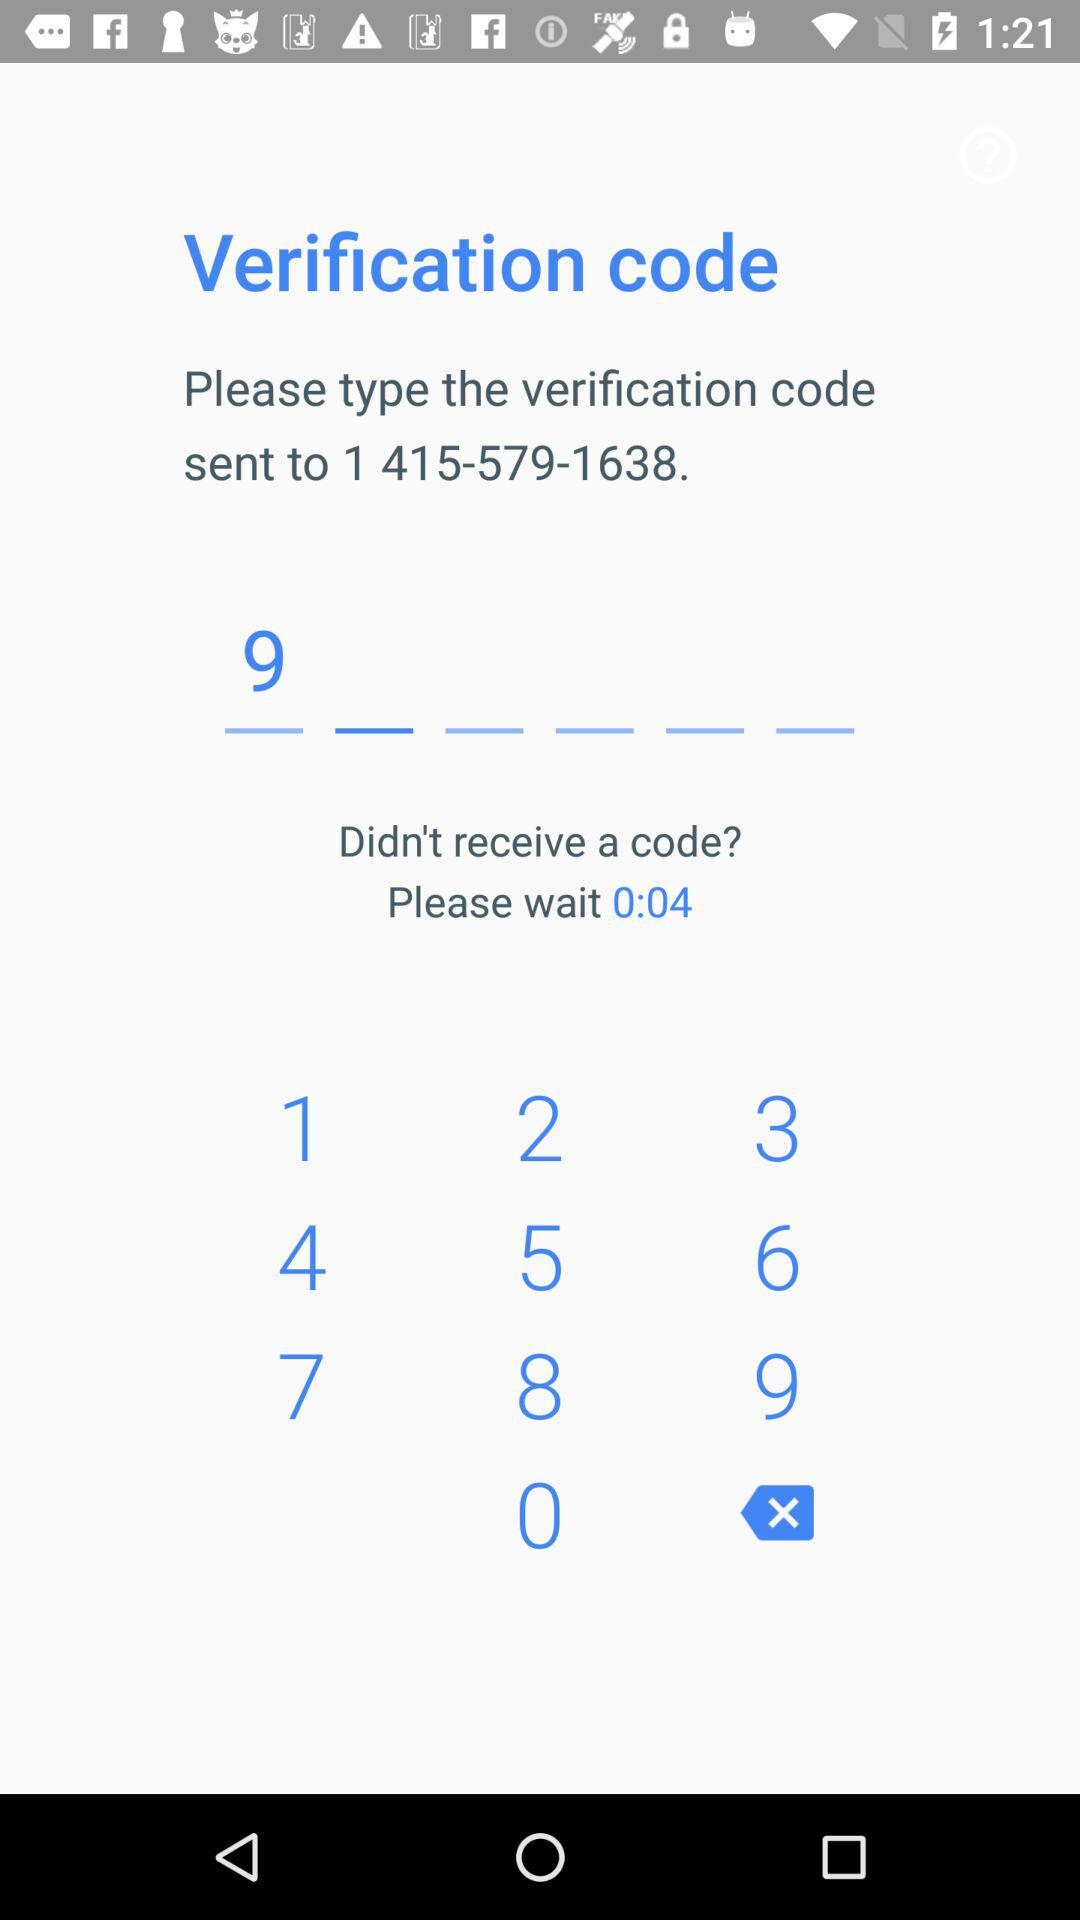How many digits are in the verification code?
Answer the question using a single word or phrase. 6 